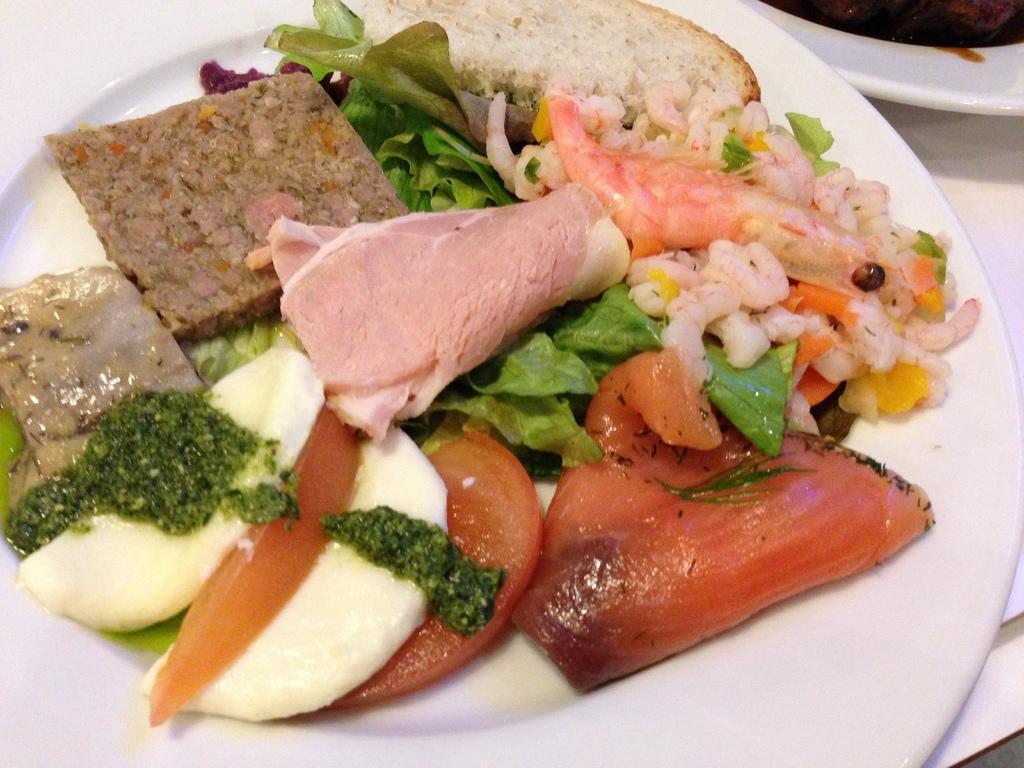Can you describe this image briefly? In this image there is a table with two plates on it and on the plates there is a salad and a food item. 